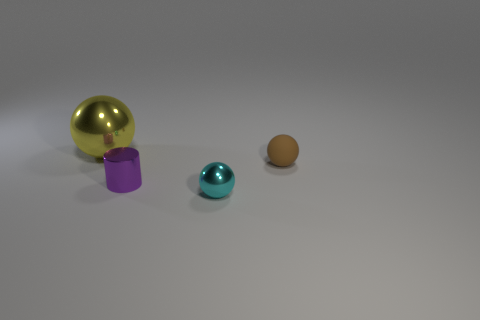What number of brown rubber things are the same shape as the big shiny object?
Your answer should be compact. 1. How many yellow things are either tiny objects or tiny matte spheres?
Offer a very short reply. 0. There is a metallic sphere to the left of the metallic sphere that is in front of the large object; what is its size?
Ensure brevity in your answer.  Large. There is a big yellow thing that is the same shape as the cyan object; what material is it?
Your response must be concise. Metal. What number of other spheres have the same size as the cyan metal ball?
Provide a short and direct response. 1. Is the size of the brown thing the same as the purple cylinder?
Offer a very short reply. Yes. What size is the ball that is on the left side of the brown matte sphere and behind the tiny purple metal object?
Make the answer very short. Large. Is the number of tiny metal spheres that are behind the brown matte object greater than the number of shiny things on the right side of the tiny cyan thing?
Offer a very short reply. No. What is the color of the other tiny shiny object that is the same shape as the yellow shiny thing?
Give a very brief answer. Cyan. Do the small ball that is behind the small cyan metal object and the big metallic thing have the same color?
Your response must be concise. No. 